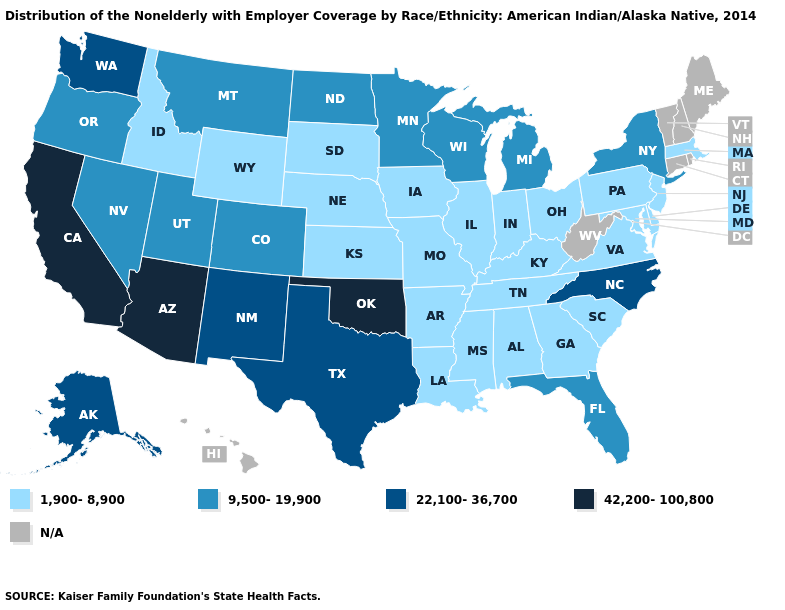Name the states that have a value in the range 42,200-100,800?
Quick response, please. Arizona, California, Oklahoma. Is the legend a continuous bar?
Be succinct. No. Name the states that have a value in the range 22,100-36,700?
Answer briefly. Alaska, New Mexico, North Carolina, Texas, Washington. Does Michigan have the lowest value in the MidWest?
Quick response, please. No. Which states hav the highest value in the South?
Quick response, please. Oklahoma. What is the highest value in states that border Vermont?
Quick response, please. 9,500-19,900. Among the states that border Georgia , does North Carolina have the highest value?
Keep it brief. Yes. Which states hav the highest value in the Northeast?
Give a very brief answer. New York. Name the states that have a value in the range 22,100-36,700?
Concise answer only. Alaska, New Mexico, North Carolina, Texas, Washington. Does the first symbol in the legend represent the smallest category?
Give a very brief answer. Yes. What is the lowest value in the MidWest?
Keep it brief. 1,900-8,900. Is the legend a continuous bar?
Keep it brief. No. Among the states that border Illinois , which have the lowest value?
Short answer required. Indiana, Iowa, Kentucky, Missouri. Name the states that have a value in the range 42,200-100,800?
Quick response, please. Arizona, California, Oklahoma. 